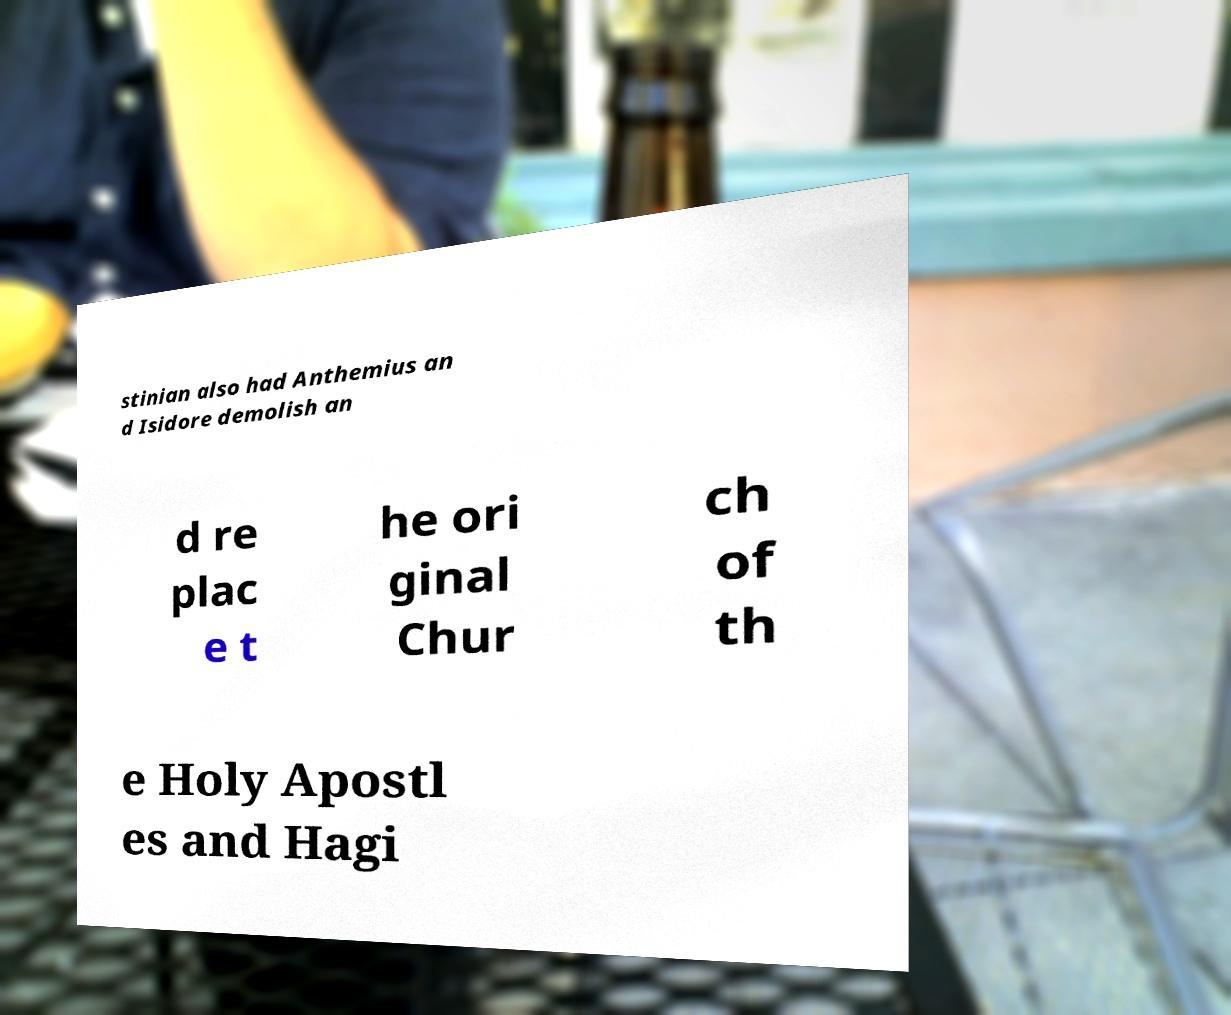I need the written content from this picture converted into text. Can you do that? stinian also had Anthemius an d Isidore demolish an d re plac e t he ori ginal Chur ch of th e Holy Apostl es and Hagi 